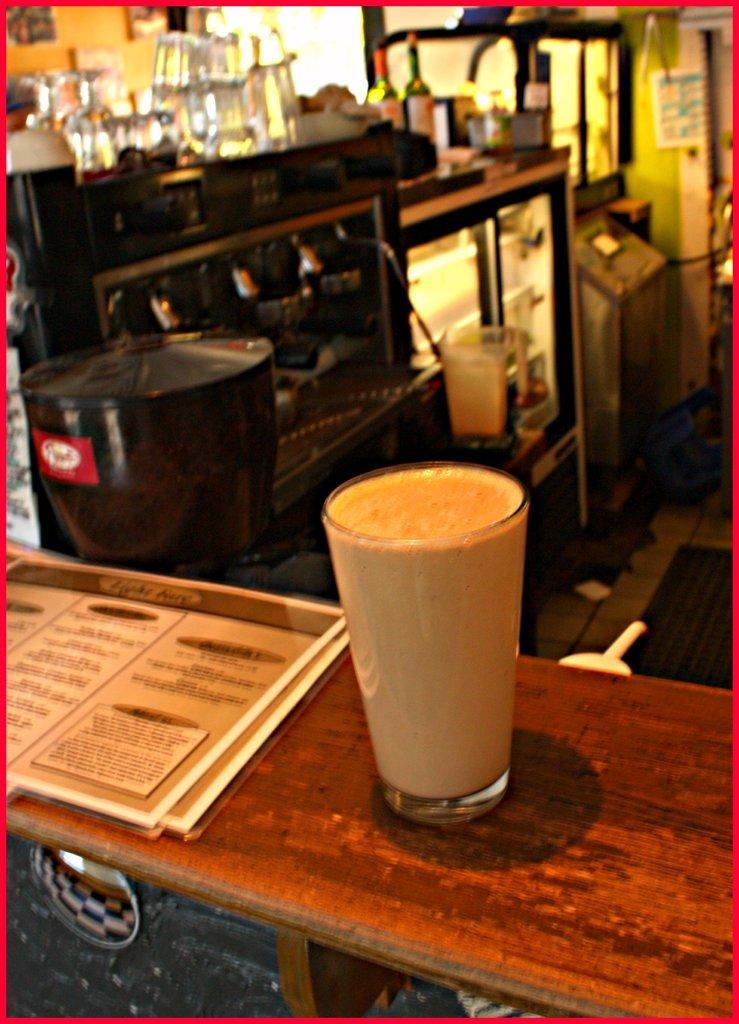What type of glass is visible in the image? There is a milkshake glass in the image. What else can be seen in the image besides the milkshake glass? There is a menu card in the image. Where is the menu card located in relation to the milkshake glass? The menu card is beside the milkshake glass. What does the mother remember about the love she had for the milkshake glass in the image? There is no mention of a mother or any personal memories in the image, as it only features a milkshake glass and a menu card. 